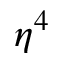<formula> <loc_0><loc_0><loc_500><loc_500>\eta ^ { 4 }</formula> 